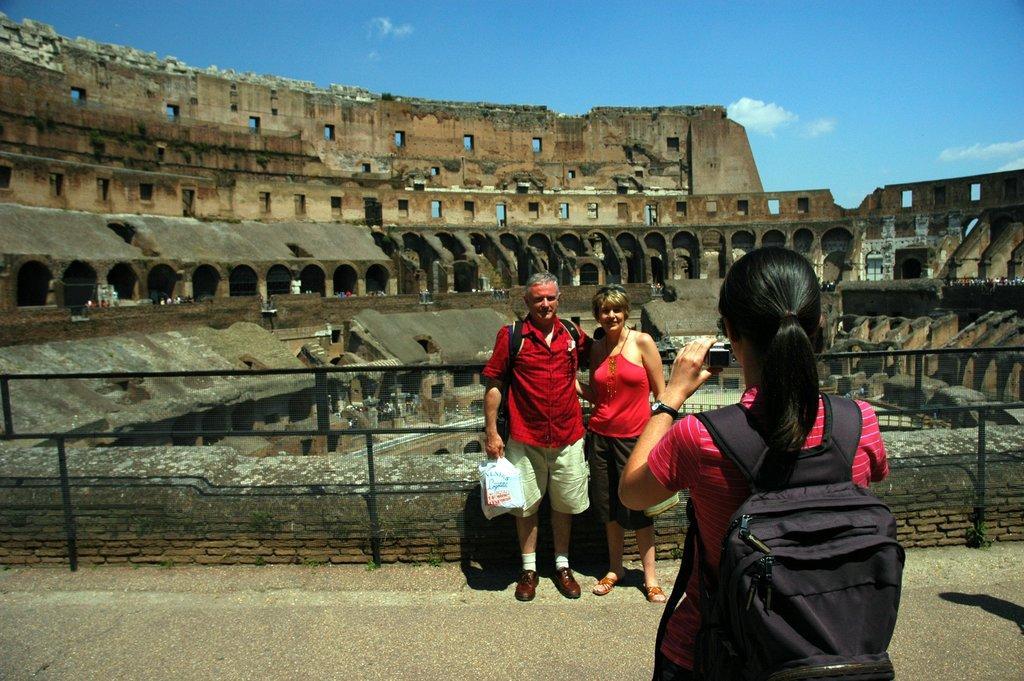Could you give a brief overview of what you see in this image? In this picture there are two people and a girl is clicking an image of them. In the background there is a historical monument. 